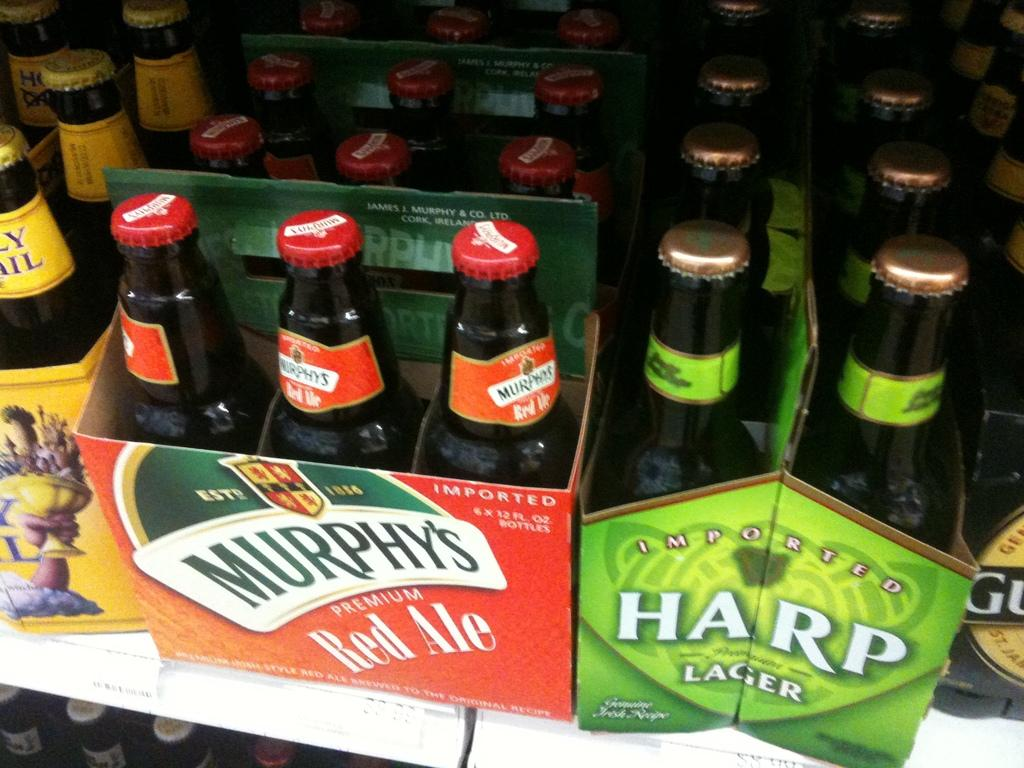<image>
Render a clear and concise summary of the photo. A six pack of Murphy's red ale and a six pack of Harp lager sitting on a store shelf. 